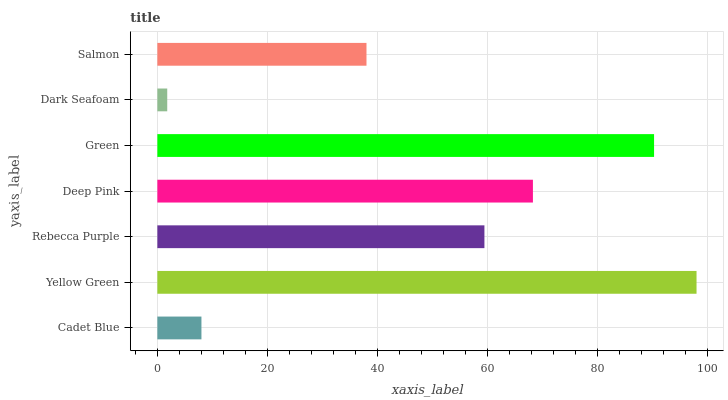Is Dark Seafoam the minimum?
Answer yes or no. Yes. Is Yellow Green the maximum?
Answer yes or no. Yes. Is Rebecca Purple the minimum?
Answer yes or no. No. Is Rebecca Purple the maximum?
Answer yes or no. No. Is Yellow Green greater than Rebecca Purple?
Answer yes or no. Yes. Is Rebecca Purple less than Yellow Green?
Answer yes or no. Yes. Is Rebecca Purple greater than Yellow Green?
Answer yes or no. No. Is Yellow Green less than Rebecca Purple?
Answer yes or no. No. Is Rebecca Purple the high median?
Answer yes or no. Yes. Is Rebecca Purple the low median?
Answer yes or no. Yes. Is Deep Pink the high median?
Answer yes or no. No. Is Salmon the low median?
Answer yes or no. No. 